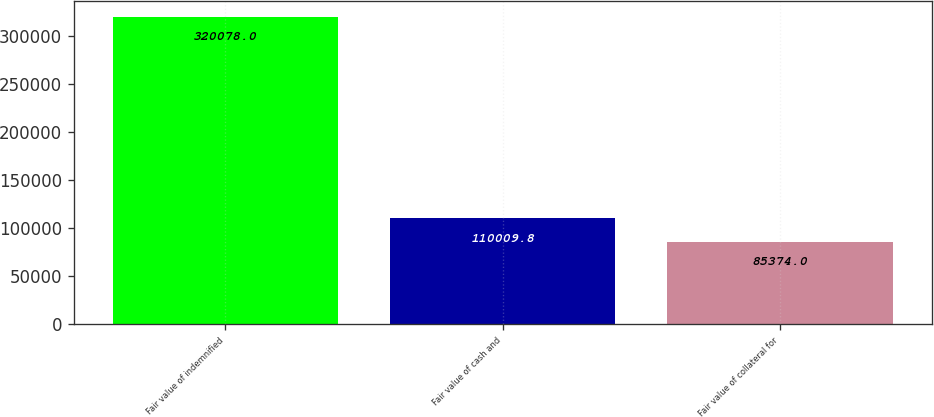Convert chart. <chart><loc_0><loc_0><loc_500><loc_500><bar_chart><fcel>Fair value of indemnified<fcel>Fair value of cash and<fcel>Fair value of collateral for<nl><fcel>320078<fcel>110010<fcel>85374<nl></chart> 